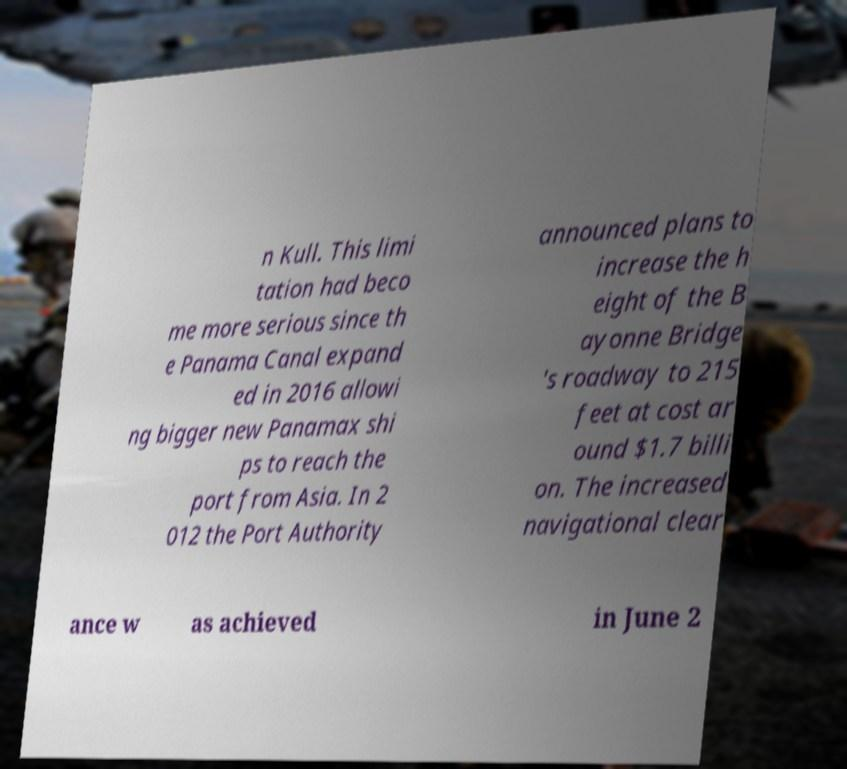I need the written content from this picture converted into text. Can you do that? n Kull. This limi tation had beco me more serious since th e Panama Canal expand ed in 2016 allowi ng bigger new Panamax shi ps to reach the port from Asia. In 2 012 the Port Authority announced plans to increase the h eight of the B ayonne Bridge 's roadway to 215 feet at cost ar ound $1.7 billi on. The increased navigational clear ance w as achieved in June 2 